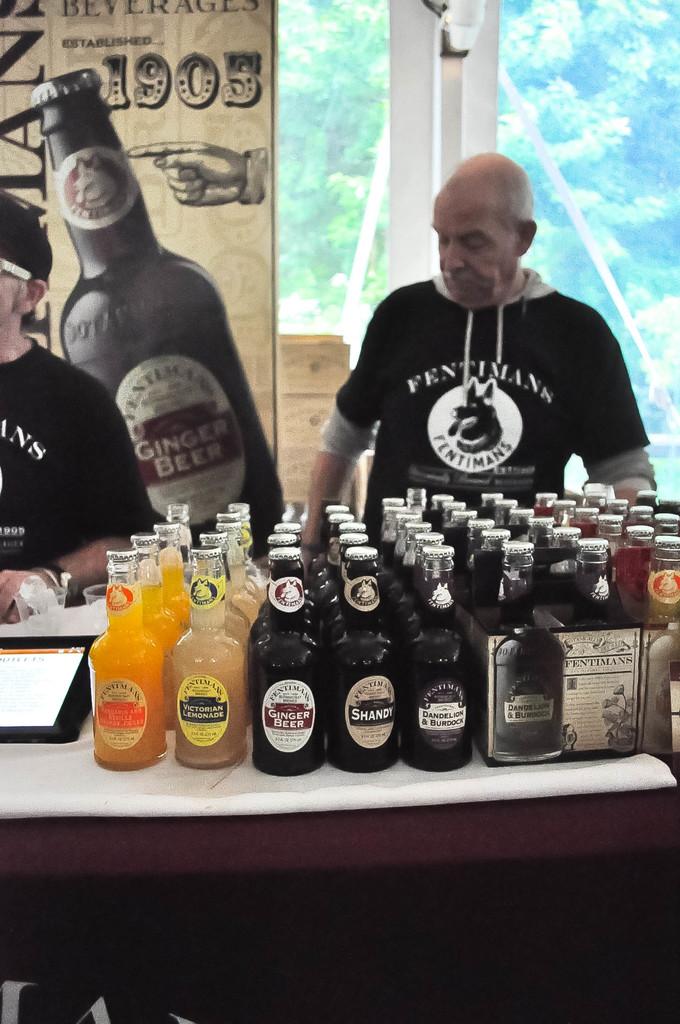What year was the company established?
Ensure brevity in your answer.  1905. 